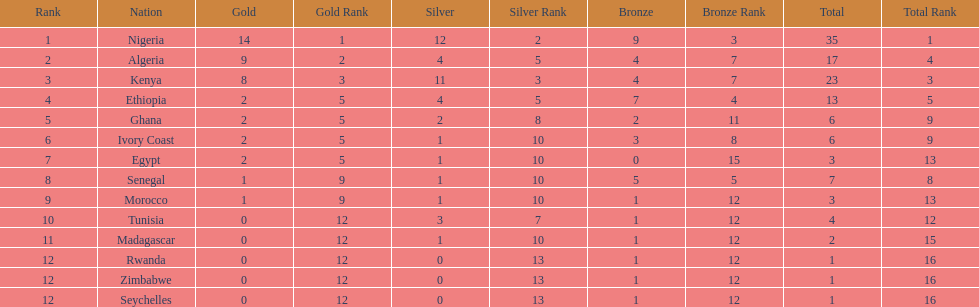What is the name of the only nation that did not earn any bronze medals? Egypt. 